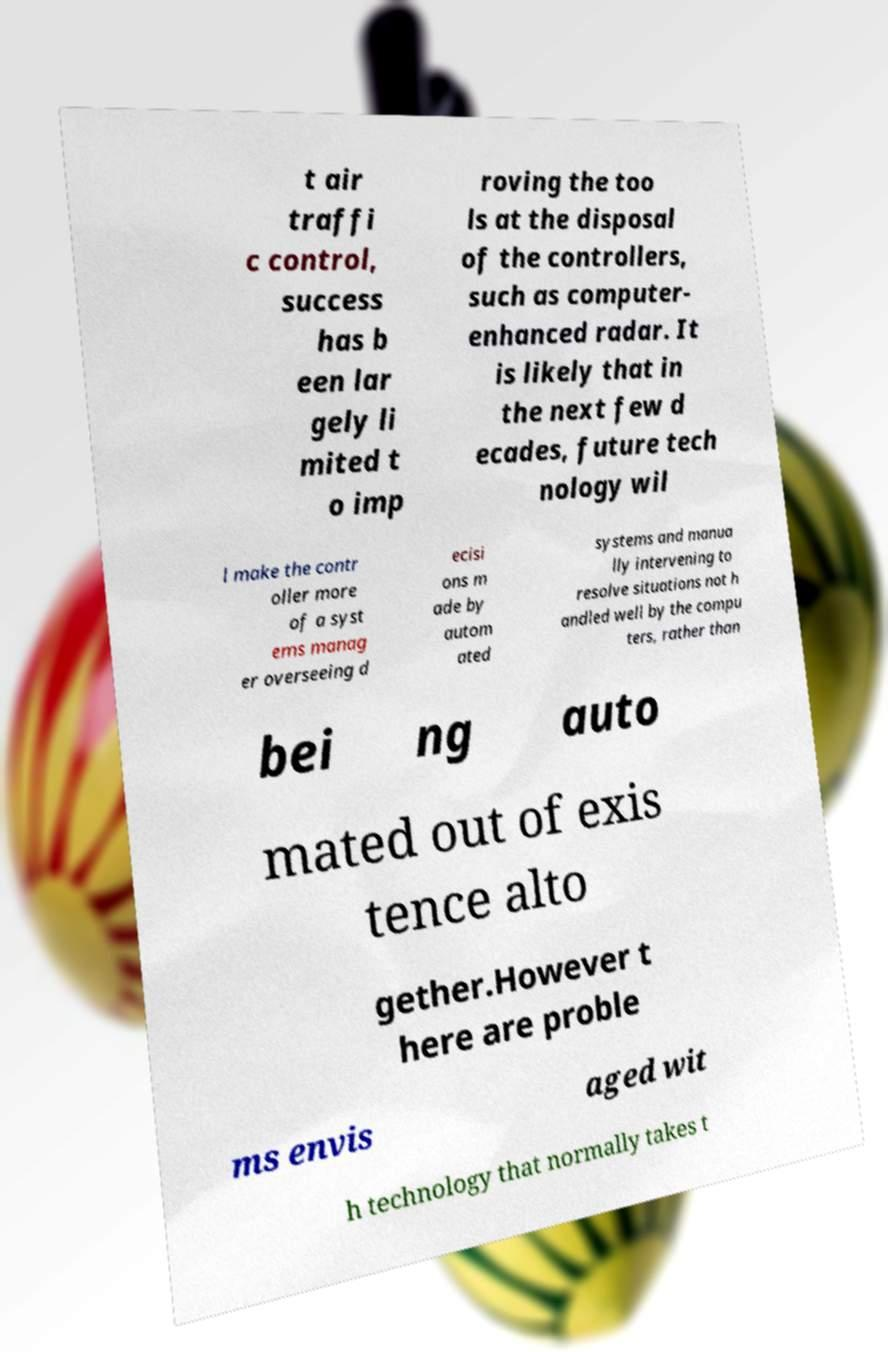Could you extract and type out the text from this image? t air traffi c control, success has b een lar gely li mited t o imp roving the too ls at the disposal of the controllers, such as computer- enhanced radar. It is likely that in the next few d ecades, future tech nology wil l make the contr oller more of a syst ems manag er overseeing d ecisi ons m ade by autom ated systems and manua lly intervening to resolve situations not h andled well by the compu ters, rather than bei ng auto mated out of exis tence alto gether.However t here are proble ms envis aged wit h technology that normally takes t 